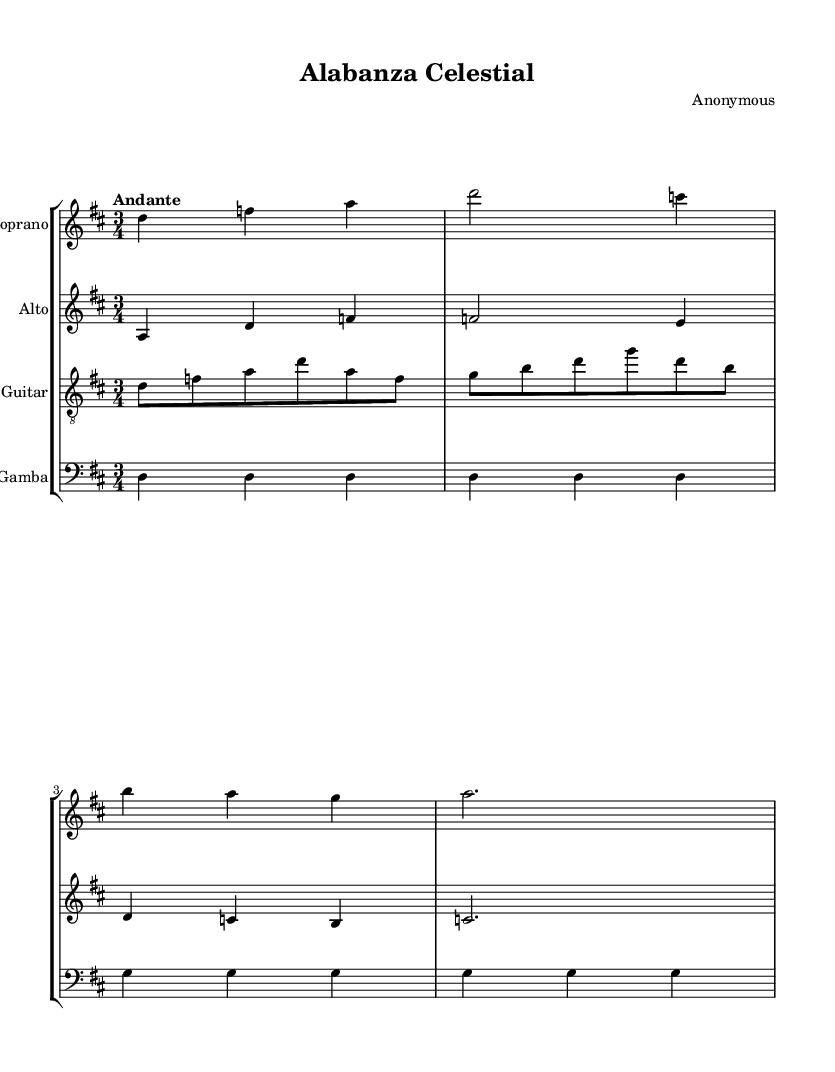What is the key signature of this music? The key signature is indicated by the two sharps at the beginning of the staff, which corresponds to D major.
Answer: D major What is the time signature of the piece? The time signature appears as a fraction at the beginning of the score, specifically 3 over 4, indicating three beats per measure.
Answer: 3/4 What is the tempo marking for this piece? The tempo marking is indicated in Italian at the beginning of the score, which states "Andante", implying a moderately slow pace.
Answer: Andante How many voices are present in this composition? The score shows four musical staves, each representing a different voice or instrument, indicating that there are four voices in total.
Answer: Four Which instruments are included in the score? The composition includes a Soprano, Alto, Baroque Guitar, and Viola da Gamba, as noted in the instrument names on each staff.
Answer: Soprano, Alto, Baroque Guitar, Viola da Gamba What is the rhythmic pattern observed in the guitar part? The guitar section starts with eight notes followed by a repetition of quarter notes, revealing a syncopated rhythmic cell common to Baroque music.
Answer: Syncopated What structure does this piece follow? The composition adheres to a traditional form often found in sacred music, where the phrases often parallel the sacred text, structured in repeating sections typical to choral works.
Answer: Repeating sections 